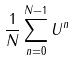Convert formula to latex. <formula><loc_0><loc_0><loc_500><loc_500>\frac { 1 } { N } \sum _ { n = 0 } ^ { N - 1 } U ^ { n }</formula> 